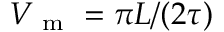<formula> <loc_0><loc_0><loc_500><loc_500>V _ { m } = \pi L / ( 2 \tau )</formula> 